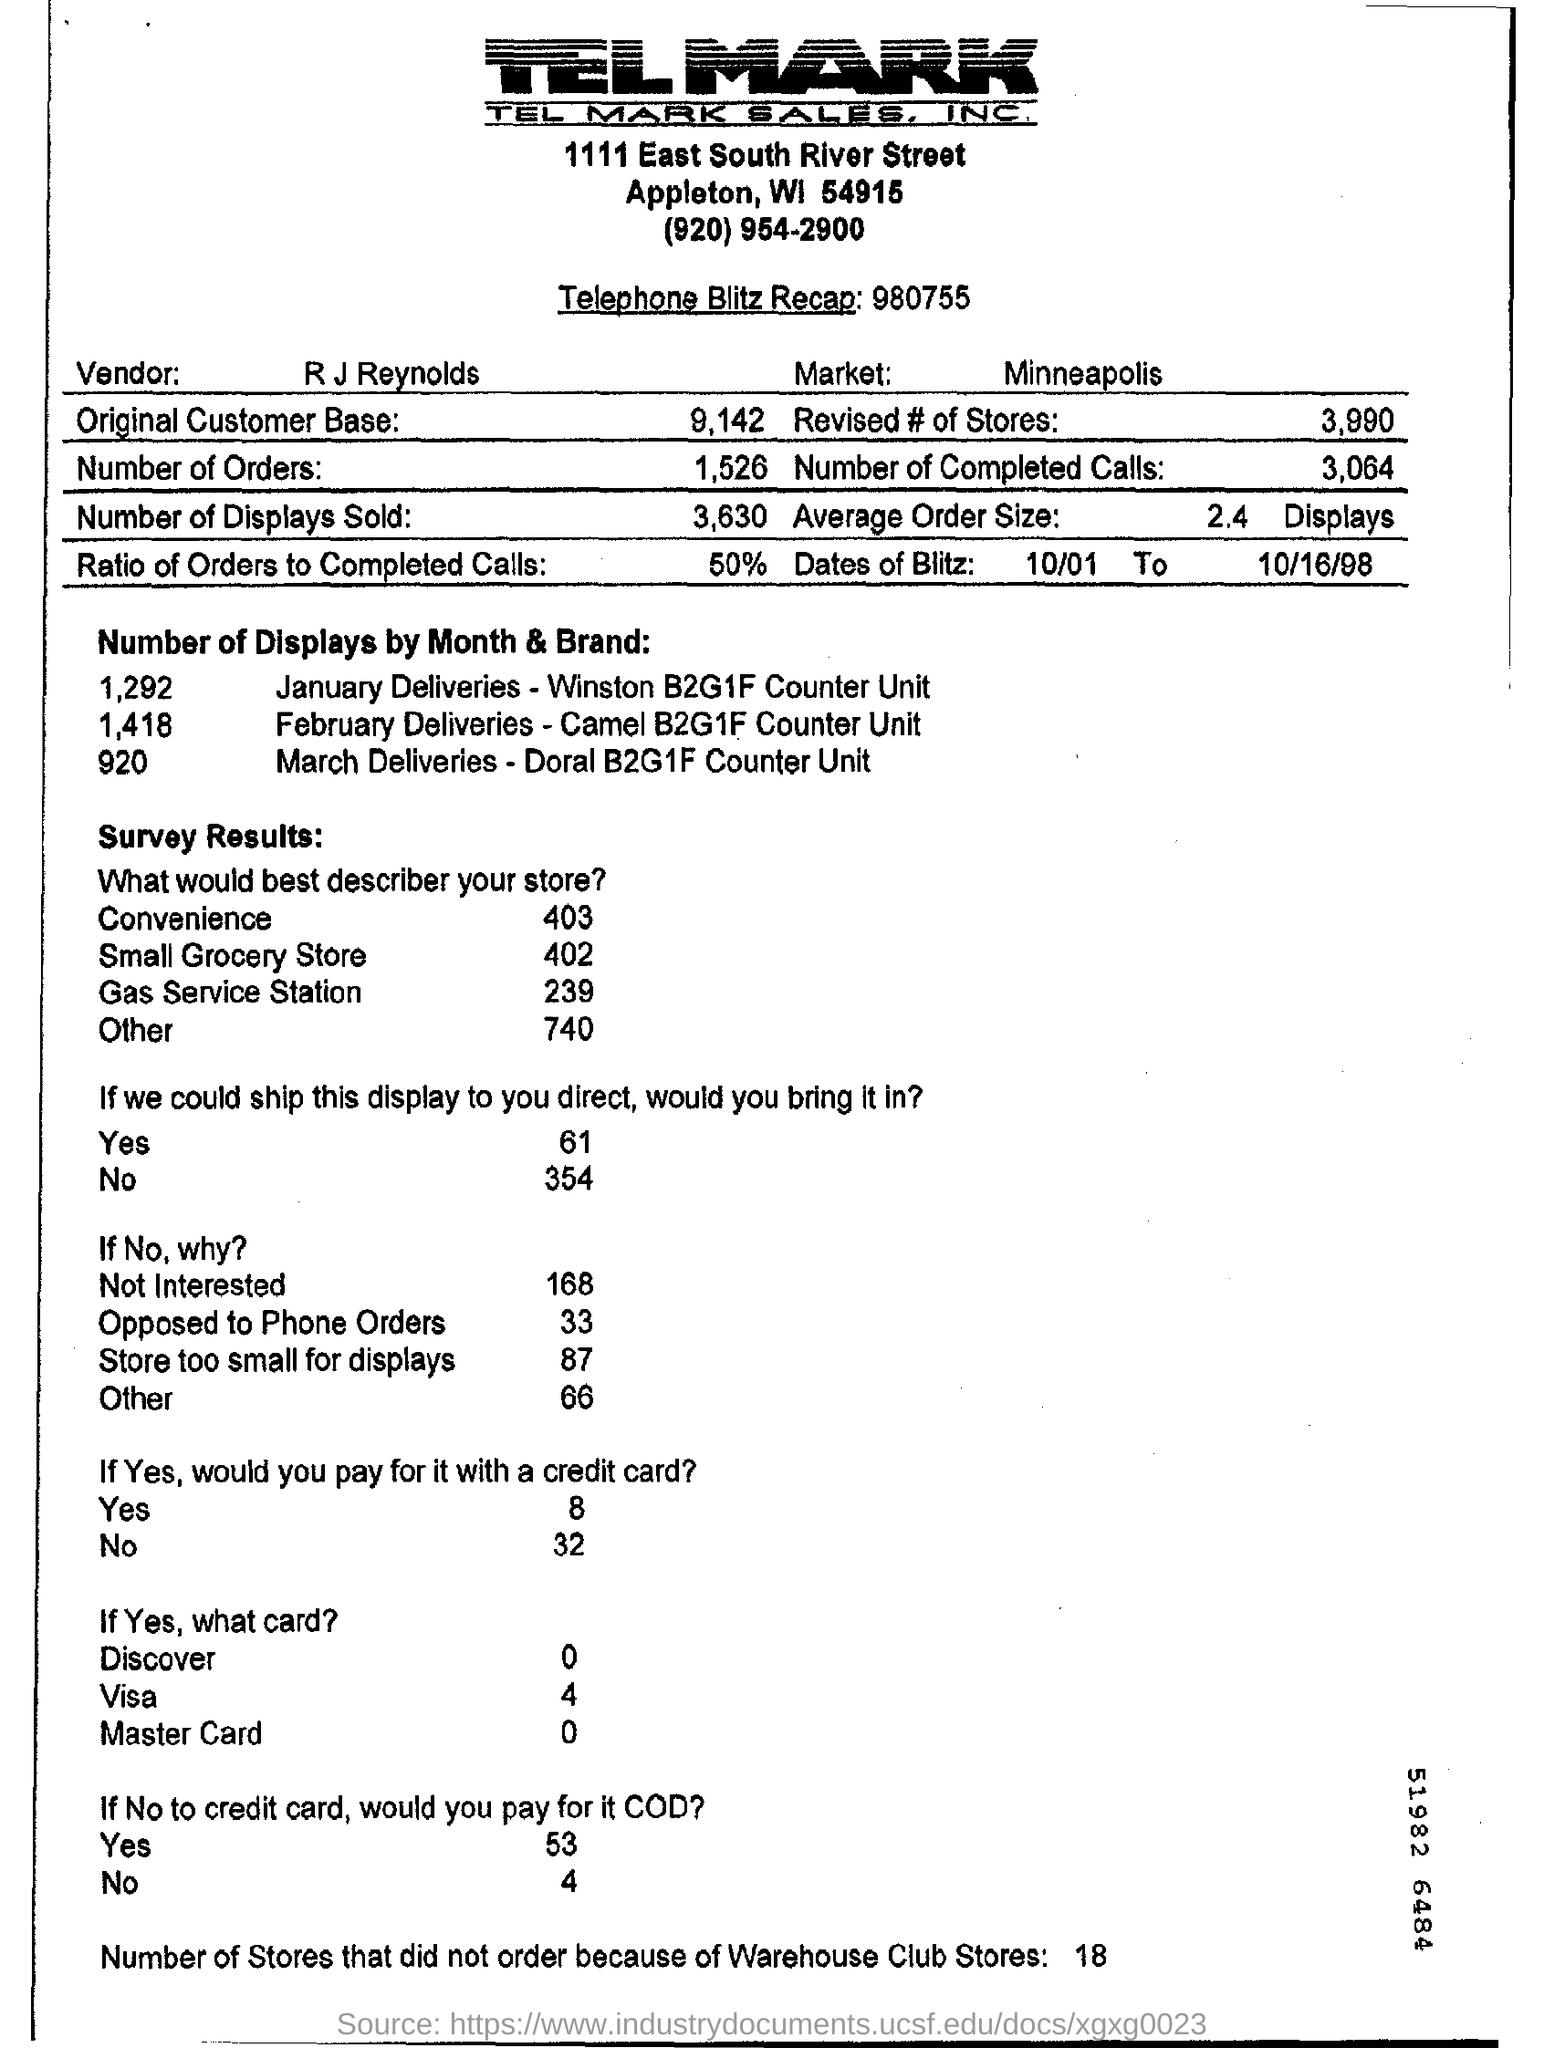What is the telephone blitz recap given?
Offer a terse response. 980755. What is the ratio of orders to completed calls?
Your answer should be compact. 50%. What is the average order size?
Your answer should be compact. 2.4  Displays. 